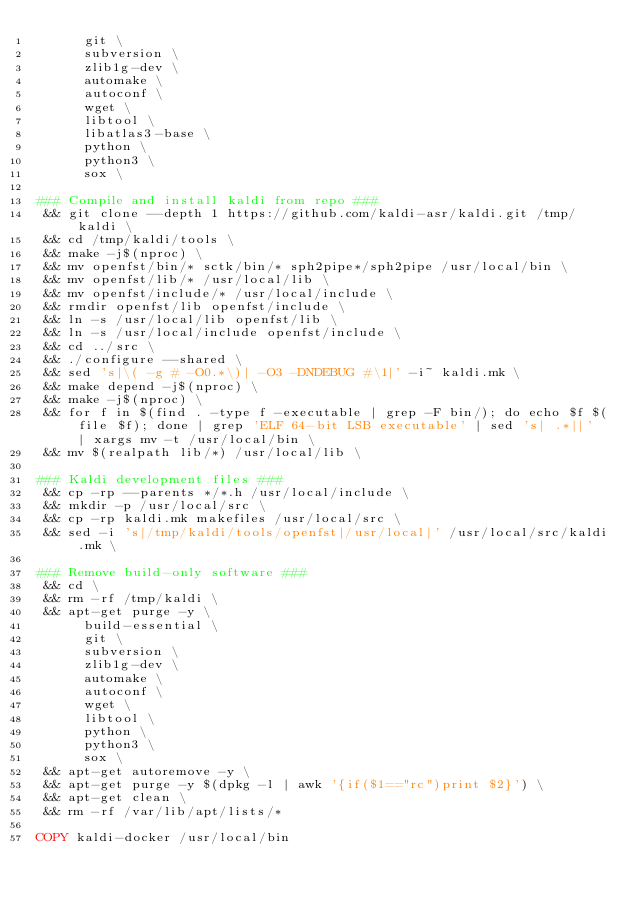Convert code to text. <code><loc_0><loc_0><loc_500><loc_500><_Dockerfile_>      git \
      subversion \
      zlib1g-dev \
      automake \
      autoconf \
      wget \
      libtool \
      libatlas3-base \
      python \
      python3 \
      sox \

### Compile and install kaldi from repo ###
 && git clone --depth 1 https://github.com/kaldi-asr/kaldi.git /tmp/kaldi \
 && cd /tmp/kaldi/tools \
 && make -j$(nproc) \
 && mv openfst/bin/* sctk/bin/* sph2pipe*/sph2pipe /usr/local/bin \
 && mv openfst/lib/* /usr/local/lib \
 && mv openfst/include/* /usr/local/include \
 && rmdir openfst/lib openfst/include \
 && ln -s /usr/local/lib openfst/lib \
 && ln -s /usr/local/include openfst/include \
 && cd ../src \
 && ./configure --shared \
 && sed 's|\( -g # -O0.*\)| -O3 -DNDEBUG #\1|' -i~ kaldi.mk \
 && make depend -j$(nproc) \
 && make -j$(nproc) \
 && for f in $(find . -type f -executable | grep -F bin/); do echo $f $(file $f); done | grep 'ELF 64-bit LSB executable' | sed 's| .*||' | xargs mv -t /usr/local/bin \
 && mv $(realpath lib/*) /usr/local/lib \

### Kaldi development files ###
 && cp -rp --parents */*.h /usr/local/include \
 && mkdir -p /usr/local/src \
 && cp -rp kaldi.mk makefiles /usr/local/src \
 && sed -i 's|/tmp/kaldi/tools/openfst|/usr/local|' /usr/local/src/kaldi.mk \

### Remove build-only software ###
 && cd \
 && rm -rf /tmp/kaldi \
 && apt-get purge -y \
      build-essential \
      git \
      subversion \
      zlib1g-dev \
      automake \
      autoconf \
      wget \
      libtool \
      python \
      python3 \
      sox \
 && apt-get autoremove -y \
 && apt-get purge -y $(dpkg -l | awk '{if($1=="rc")print $2}') \
 && apt-get clean \
 && rm -rf /var/lib/apt/lists/*

COPY kaldi-docker /usr/local/bin
</code> 